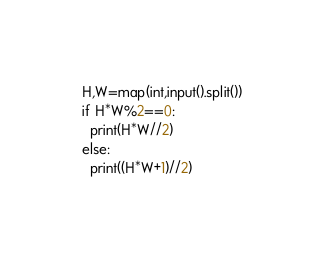<code> <loc_0><loc_0><loc_500><loc_500><_Python_>H,W=map(int,input().split())
if H*W%2==0:
  print(H*W//2)
else:
  print((H*W+1)//2)</code> 